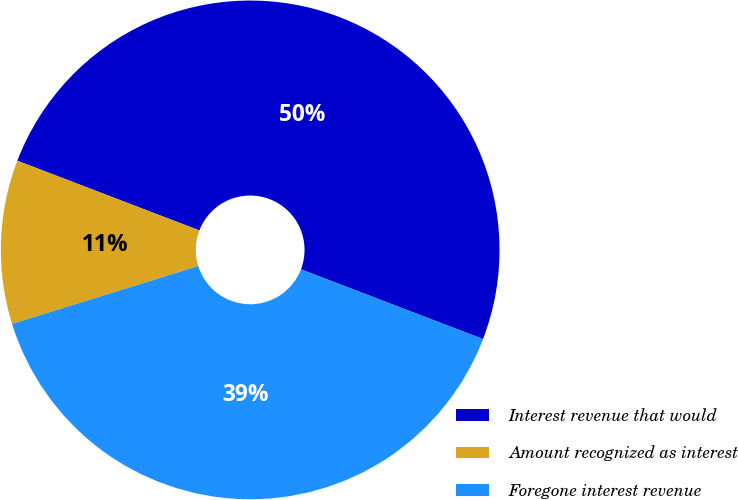<chart> <loc_0><loc_0><loc_500><loc_500><pie_chart><fcel>Interest revenue that would<fcel>Amount recognized as interest<fcel>Foregone interest revenue<nl><fcel>50.0%<fcel>10.62%<fcel>39.38%<nl></chart> 